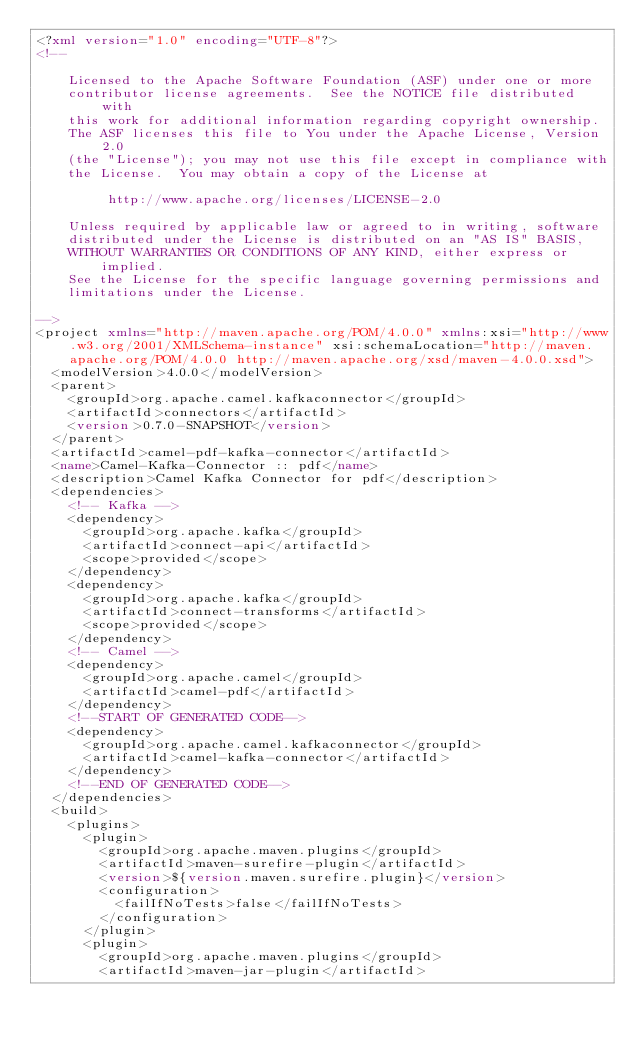Convert code to text. <code><loc_0><loc_0><loc_500><loc_500><_XML_><?xml version="1.0" encoding="UTF-8"?>
<!--

    Licensed to the Apache Software Foundation (ASF) under one or more
    contributor license agreements.  See the NOTICE file distributed with
    this work for additional information regarding copyright ownership.
    The ASF licenses this file to You under the Apache License, Version 2.0
    (the "License"); you may not use this file except in compliance with
    the License.  You may obtain a copy of the License at

         http://www.apache.org/licenses/LICENSE-2.0

    Unless required by applicable law or agreed to in writing, software
    distributed under the License is distributed on an "AS IS" BASIS,
    WITHOUT WARRANTIES OR CONDITIONS OF ANY KIND, either express or implied.
    See the License for the specific language governing permissions and
    limitations under the License.

-->
<project xmlns="http://maven.apache.org/POM/4.0.0" xmlns:xsi="http://www.w3.org/2001/XMLSchema-instance" xsi:schemaLocation="http://maven.apache.org/POM/4.0.0 http://maven.apache.org/xsd/maven-4.0.0.xsd">
  <modelVersion>4.0.0</modelVersion>
  <parent>
    <groupId>org.apache.camel.kafkaconnector</groupId>
    <artifactId>connectors</artifactId>
    <version>0.7.0-SNAPSHOT</version>
  </parent>
  <artifactId>camel-pdf-kafka-connector</artifactId>
  <name>Camel-Kafka-Connector :: pdf</name>
  <description>Camel Kafka Connector for pdf</description>
  <dependencies>
    <!-- Kafka -->
    <dependency>
      <groupId>org.apache.kafka</groupId>
      <artifactId>connect-api</artifactId>
      <scope>provided</scope>
    </dependency>
    <dependency>
      <groupId>org.apache.kafka</groupId>
      <artifactId>connect-transforms</artifactId>
      <scope>provided</scope>
    </dependency>
    <!-- Camel -->
    <dependency>
      <groupId>org.apache.camel</groupId>
      <artifactId>camel-pdf</artifactId>
    </dependency>
    <!--START OF GENERATED CODE-->
    <dependency>
      <groupId>org.apache.camel.kafkaconnector</groupId>
      <artifactId>camel-kafka-connector</artifactId>
    </dependency>
    <!--END OF GENERATED CODE-->
  </dependencies>
  <build>
    <plugins>
      <plugin>
        <groupId>org.apache.maven.plugins</groupId>
        <artifactId>maven-surefire-plugin</artifactId>
        <version>${version.maven.surefire.plugin}</version>
        <configuration>
          <failIfNoTests>false</failIfNoTests>
        </configuration>
      </plugin>
      <plugin>
        <groupId>org.apache.maven.plugins</groupId>
        <artifactId>maven-jar-plugin</artifactId></code> 